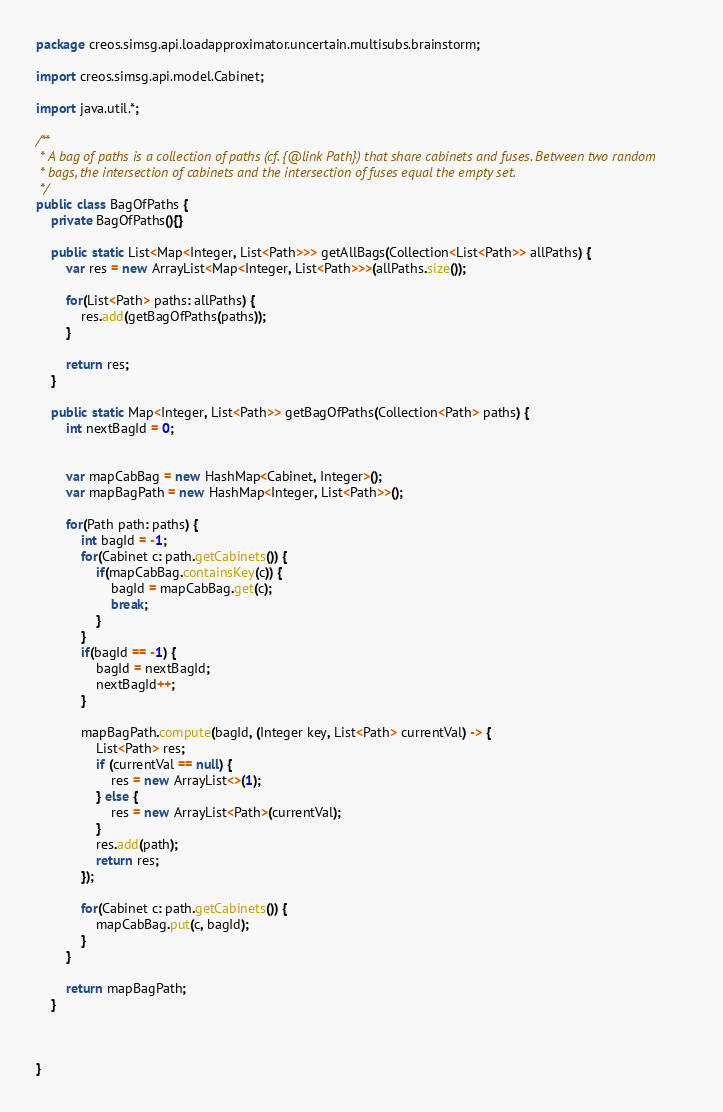Convert code to text. <code><loc_0><loc_0><loc_500><loc_500><_Java_>package creos.simsg.api.loadapproximator.uncertain.multisubs.brainstorm;

import creos.simsg.api.model.Cabinet;

import java.util.*;

/**
 * A bag of paths is a collection of paths (cf. {@link Path}) that share cabinets and fuses. Between two random
 * bags, the intersection of cabinets and the intersection of fuses equal the empty set.
 */
public class BagOfPaths {
    private BagOfPaths(){}

    public static List<Map<Integer, List<Path>>> getAllBags(Collection<List<Path>> allPaths) {
        var res = new ArrayList<Map<Integer, List<Path>>>(allPaths.size());

        for(List<Path> paths: allPaths) {
            res.add(getBagOfPaths(paths));
        }

        return res;
    }

    public static Map<Integer, List<Path>> getBagOfPaths(Collection<Path> paths) {
        int nextBagId = 0;


        var mapCabBag = new HashMap<Cabinet, Integer>();
        var mapBagPath = new HashMap<Integer, List<Path>>();

        for(Path path: paths) {
            int bagId = -1;
            for(Cabinet c: path.getCabinets()) {
                if(mapCabBag.containsKey(c)) {
                    bagId = mapCabBag.get(c);
                    break;
                }
            }
            if(bagId == -1) {
                bagId = nextBagId;
                nextBagId++;
            }

            mapBagPath.compute(bagId, (Integer key, List<Path> currentVal) -> {
                List<Path> res;
                if (currentVal == null) {
                    res = new ArrayList<>(1);
                } else {
                    res = new ArrayList<Path>(currentVal);
                }
                res.add(path);
                return res;
            });

            for(Cabinet c: path.getCabinets()) {
                mapCabBag.put(c, bagId);
            }
        }

        return mapBagPath;
    }



}
</code> 